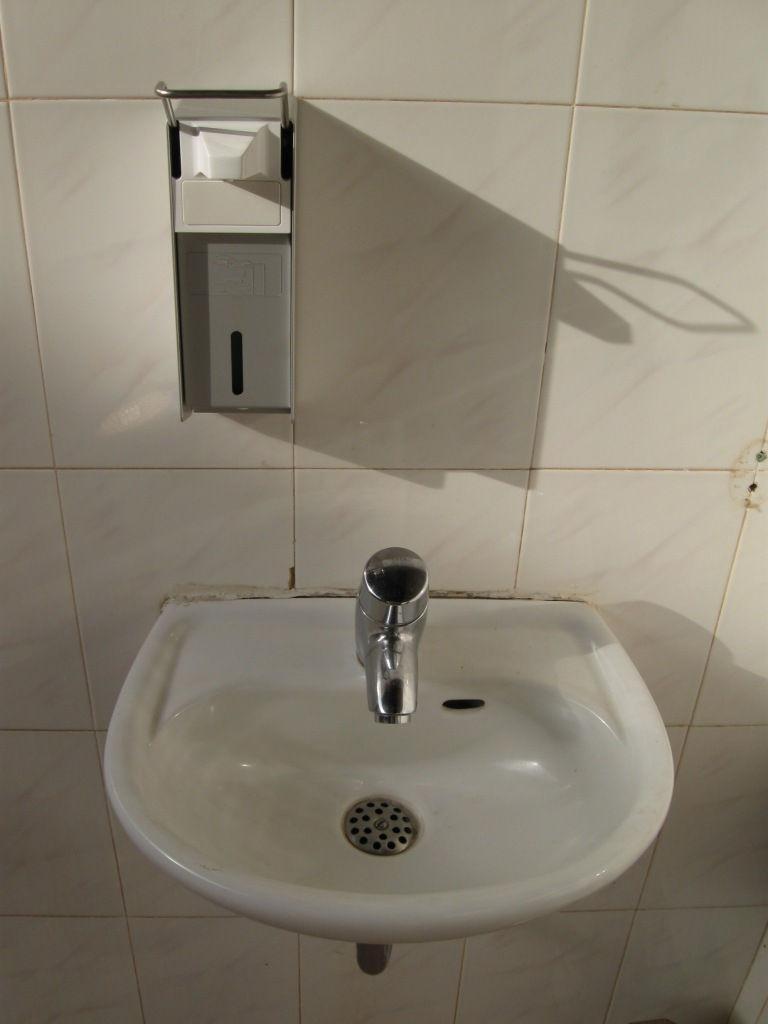Could you give a brief overview of what you see in this image? In this picture, we see a wash basin and a tap. Behind that, we see a wall which is made up of white tiles. We see a tissue stand or a sanitizer box. 